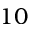<formula> <loc_0><loc_0><loc_500><loc_500>1 0</formula> 